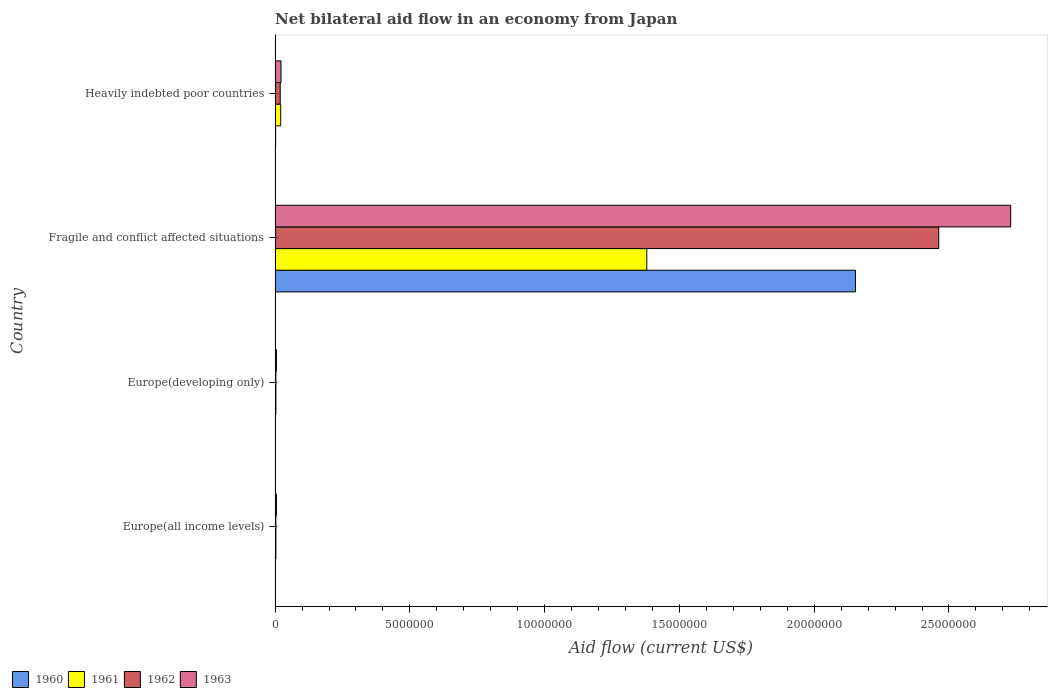How many different coloured bars are there?
Your answer should be very brief. 4. How many groups of bars are there?
Provide a succinct answer. 4. Are the number of bars on each tick of the Y-axis equal?
Ensure brevity in your answer.  Yes. How many bars are there on the 3rd tick from the top?
Ensure brevity in your answer.  4. What is the label of the 4th group of bars from the top?
Provide a short and direct response. Europe(all income levels). Across all countries, what is the maximum net bilateral aid flow in 1962?
Keep it short and to the point. 2.46e+07. In which country was the net bilateral aid flow in 1960 maximum?
Keep it short and to the point. Fragile and conflict affected situations. In which country was the net bilateral aid flow in 1962 minimum?
Provide a short and direct response. Europe(all income levels). What is the total net bilateral aid flow in 1960 in the graph?
Provide a short and direct response. 2.16e+07. What is the difference between the net bilateral aid flow in 1962 in Europe(all income levels) and that in Fragile and conflict affected situations?
Make the answer very short. -2.46e+07. What is the difference between the net bilateral aid flow in 1960 in Fragile and conflict affected situations and the net bilateral aid flow in 1962 in Europe(developing only)?
Your answer should be compact. 2.15e+07. What is the average net bilateral aid flow in 1963 per country?
Make the answer very short. 6.90e+06. What is the ratio of the net bilateral aid flow in 1962 in Europe(all income levels) to that in Europe(developing only)?
Provide a succinct answer. 1. Is the difference between the net bilateral aid flow in 1963 in Fragile and conflict affected situations and Heavily indebted poor countries greater than the difference between the net bilateral aid flow in 1961 in Fragile and conflict affected situations and Heavily indebted poor countries?
Ensure brevity in your answer.  Yes. What is the difference between the highest and the second highest net bilateral aid flow in 1961?
Your answer should be compact. 1.36e+07. What is the difference between the highest and the lowest net bilateral aid flow in 1963?
Provide a succinct answer. 2.72e+07. What does the 4th bar from the top in Europe(developing only) represents?
Your answer should be very brief. 1960. Are all the bars in the graph horizontal?
Keep it short and to the point. Yes. What is the difference between two consecutive major ticks on the X-axis?
Provide a succinct answer. 5.00e+06. Are the values on the major ticks of X-axis written in scientific E-notation?
Ensure brevity in your answer.  No. Does the graph contain any zero values?
Offer a terse response. No. Does the graph contain grids?
Give a very brief answer. No. Where does the legend appear in the graph?
Keep it short and to the point. Bottom left. How many legend labels are there?
Make the answer very short. 4. What is the title of the graph?
Ensure brevity in your answer.  Net bilateral aid flow in an economy from Japan. Does "2003" appear as one of the legend labels in the graph?
Offer a very short reply. No. What is the Aid flow (current US$) of 1961 in Europe(all income levels)?
Your response must be concise. 3.00e+04. What is the Aid flow (current US$) of 1962 in Europe(all income levels)?
Make the answer very short. 3.00e+04. What is the Aid flow (current US$) in 1960 in Fragile and conflict affected situations?
Your answer should be compact. 2.15e+07. What is the Aid flow (current US$) of 1961 in Fragile and conflict affected situations?
Provide a succinct answer. 1.38e+07. What is the Aid flow (current US$) of 1962 in Fragile and conflict affected situations?
Ensure brevity in your answer.  2.46e+07. What is the Aid flow (current US$) of 1963 in Fragile and conflict affected situations?
Make the answer very short. 2.73e+07. What is the Aid flow (current US$) in 1962 in Heavily indebted poor countries?
Make the answer very short. 1.90e+05. What is the Aid flow (current US$) in 1963 in Heavily indebted poor countries?
Your response must be concise. 2.20e+05. Across all countries, what is the maximum Aid flow (current US$) of 1960?
Ensure brevity in your answer.  2.15e+07. Across all countries, what is the maximum Aid flow (current US$) of 1961?
Provide a short and direct response. 1.38e+07. Across all countries, what is the maximum Aid flow (current US$) in 1962?
Ensure brevity in your answer.  2.46e+07. Across all countries, what is the maximum Aid flow (current US$) in 1963?
Your answer should be very brief. 2.73e+07. Across all countries, what is the minimum Aid flow (current US$) of 1962?
Offer a very short reply. 3.00e+04. What is the total Aid flow (current US$) of 1960 in the graph?
Offer a terse response. 2.16e+07. What is the total Aid flow (current US$) in 1961 in the graph?
Offer a very short reply. 1.41e+07. What is the total Aid flow (current US$) of 1962 in the graph?
Give a very brief answer. 2.49e+07. What is the total Aid flow (current US$) in 1963 in the graph?
Your answer should be very brief. 2.76e+07. What is the difference between the Aid flow (current US$) in 1961 in Europe(all income levels) and that in Europe(developing only)?
Make the answer very short. 0. What is the difference between the Aid flow (current US$) in 1962 in Europe(all income levels) and that in Europe(developing only)?
Your answer should be very brief. 0. What is the difference between the Aid flow (current US$) of 1963 in Europe(all income levels) and that in Europe(developing only)?
Give a very brief answer. 0. What is the difference between the Aid flow (current US$) of 1960 in Europe(all income levels) and that in Fragile and conflict affected situations?
Give a very brief answer. -2.15e+07. What is the difference between the Aid flow (current US$) in 1961 in Europe(all income levels) and that in Fragile and conflict affected situations?
Your answer should be very brief. -1.38e+07. What is the difference between the Aid flow (current US$) in 1962 in Europe(all income levels) and that in Fragile and conflict affected situations?
Ensure brevity in your answer.  -2.46e+07. What is the difference between the Aid flow (current US$) in 1963 in Europe(all income levels) and that in Fragile and conflict affected situations?
Give a very brief answer. -2.72e+07. What is the difference between the Aid flow (current US$) of 1961 in Europe(all income levels) and that in Heavily indebted poor countries?
Your answer should be very brief. -1.80e+05. What is the difference between the Aid flow (current US$) in 1962 in Europe(all income levels) and that in Heavily indebted poor countries?
Offer a very short reply. -1.60e+05. What is the difference between the Aid flow (current US$) of 1960 in Europe(developing only) and that in Fragile and conflict affected situations?
Provide a succinct answer. -2.15e+07. What is the difference between the Aid flow (current US$) of 1961 in Europe(developing only) and that in Fragile and conflict affected situations?
Your answer should be compact. -1.38e+07. What is the difference between the Aid flow (current US$) in 1962 in Europe(developing only) and that in Fragile and conflict affected situations?
Your answer should be compact. -2.46e+07. What is the difference between the Aid flow (current US$) of 1963 in Europe(developing only) and that in Fragile and conflict affected situations?
Your answer should be compact. -2.72e+07. What is the difference between the Aid flow (current US$) of 1960 in Fragile and conflict affected situations and that in Heavily indebted poor countries?
Ensure brevity in your answer.  2.15e+07. What is the difference between the Aid flow (current US$) in 1961 in Fragile and conflict affected situations and that in Heavily indebted poor countries?
Your response must be concise. 1.36e+07. What is the difference between the Aid flow (current US$) of 1962 in Fragile and conflict affected situations and that in Heavily indebted poor countries?
Your answer should be very brief. 2.44e+07. What is the difference between the Aid flow (current US$) of 1963 in Fragile and conflict affected situations and that in Heavily indebted poor countries?
Provide a short and direct response. 2.71e+07. What is the difference between the Aid flow (current US$) in 1960 in Europe(all income levels) and the Aid flow (current US$) in 1961 in Europe(developing only)?
Provide a short and direct response. -2.00e+04. What is the difference between the Aid flow (current US$) in 1960 in Europe(all income levels) and the Aid flow (current US$) in 1963 in Europe(developing only)?
Provide a short and direct response. -4.00e+04. What is the difference between the Aid flow (current US$) of 1961 in Europe(all income levels) and the Aid flow (current US$) of 1962 in Europe(developing only)?
Provide a succinct answer. 0. What is the difference between the Aid flow (current US$) of 1960 in Europe(all income levels) and the Aid flow (current US$) of 1961 in Fragile and conflict affected situations?
Your answer should be compact. -1.38e+07. What is the difference between the Aid flow (current US$) in 1960 in Europe(all income levels) and the Aid flow (current US$) in 1962 in Fragile and conflict affected situations?
Keep it short and to the point. -2.46e+07. What is the difference between the Aid flow (current US$) of 1960 in Europe(all income levels) and the Aid flow (current US$) of 1963 in Fragile and conflict affected situations?
Offer a terse response. -2.73e+07. What is the difference between the Aid flow (current US$) of 1961 in Europe(all income levels) and the Aid flow (current US$) of 1962 in Fragile and conflict affected situations?
Your answer should be very brief. -2.46e+07. What is the difference between the Aid flow (current US$) in 1961 in Europe(all income levels) and the Aid flow (current US$) in 1963 in Fragile and conflict affected situations?
Give a very brief answer. -2.73e+07. What is the difference between the Aid flow (current US$) in 1962 in Europe(all income levels) and the Aid flow (current US$) in 1963 in Fragile and conflict affected situations?
Make the answer very short. -2.73e+07. What is the difference between the Aid flow (current US$) of 1960 in Europe(all income levels) and the Aid flow (current US$) of 1961 in Heavily indebted poor countries?
Your answer should be compact. -2.00e+05. What is the difference between the Aid flow (current US$) in 1960 in Europe(all income levels) and the Aid flow (current US$) in 1962 in Heavily indebted poor countries?
Offer a terse response. -1.80e+05. What is the difference between the Aid flow (current US$) of 1960 in Europe(all income levels) and the Aid flow (current US$) of 1963 in Heavily indebted poor countries?
Offer a terse response. -2.10e+05. What is the difference between the Aid flow (current US$) of 1961 in Europe(all income levels) and the Aid flow (current US$) of 1962 in Heavily indebted poor countries?
Provide a short and direct response. -1.60e+05. What is the difference between the Aid flow (current US$) in 1960 in Europe(developing only) and the Aid flow (current US$) in 1961 in Fragile and conflict affected situations?
Ensure brevity in your answer.  -1.38e+07. What is the difference between the Aid flow (current US$) of 1960 in Europe(developing only) and the Aid flow (current US$) of 1962 in Fragile and conflict affected situations?
Provide a succinct answer. -2.46e+07. What is the difference between the Aid flow (current US$) of 1960 in Europe(developing only) and the Aid flow (current US$) of 1963 in Fragile and conflict affected situations?
Give a very brief answer. -2.73e+07. What is the difference between the Aid flow (current US$) in 1961 in Europe(developing only) and the Aid flow (current US$) in 1962 in Fragile and conflict affected situations?
Your answer should be compact. -2.46e+07. What is the difference between the Aid flow (current US$) in 1961 in Europe(developing only) and the Aid flow (current US$) in 1963 in Fragile and conflict affected situations?
Your answer should be compact. -2.73e+07. What is the difference between the Aid flow (current US$) in 1962 in Europe(developing only) and the Aid flow (current US$) in 1963 in Fragile and conflict affected situations?
Make the answer very short. -2.73e+07. What is the difference between the Aid flow (current US$) in 1960 in Europe(developing only) and the Aid flow (current US$) in 1963 in Heavily indebted poor countries?
Keep it short and to the point. -2.10e+05. What is the difference between the Aid flow (current US$) of 1962 in Europe(developing only) and the Aid flow (current US$) of 1963 in Heavily indebted poor countries?
Keep it short and to the point. -1.90e+05. What is the difference between the Aid flow (current US$) in 1960 in Fragile and conflict affected situations and the Aid flow (current US$) in 1961 in Heavily indebted poor countries?
Ensure brevity in your answer.  2.13e+07. What is the difference between the Aid flow (current US$) in 1960 in Fragile and conflict affected situations and the Aid flow (current US$) in 1962 in Heavily indebted poor countries?
Your response must be concise. 2.13e+07. What is the difference between the Aid flow (current US$) in 1960 in Fragile and conflict affected situations and the Aid flow (current US$) in 1963 in Heavily indebted poor countries?
Give a very brief answer. 2.13e+07. What is the difference between the Aid flow (current US$) of 1961 in Fragile and conflict affected situations and the Aid flow (current US$) of 1962 in Heavily indebted poor countries?
Offer a terse response. 1.36e+07. What is the difference between the Aid flow (current US$) in 1961 in Fragile and conflict affected situations and the Aid flow (current US$) in 1963 in Heavily indebted poor countries?
Offer a terse response. 1.36e+07. What is the difference between the Aid flow (current US$) of 1962 in Fragile and conflict affected situations and the Aid flow (current US$) of 1963 in Heavily indebted poor countries?
Offer a very short reply. 2.44e+07. What is the average Aid flow (current US$) in 1960 per country?
Give a very brief answer. 5.39e+06. What is the average Aid flow (current US$) in 1961 per country?
Give a very brief answer. 3.52e+06. What is the average Aid flow (current US$) in 1962 per country?
Ensure brevity in your answer.  6.22e+06. What is the average Aid flow (current US$) of 1963 per country?
Give a very brief answer. 6.90e+06. What is the difference between the Aid flow (current US$) of 1960 and Aid flow (current US$) of 1961 in Europe(all income levels)?
Provide a succinct answer. -2.00e+04. What is the difference between the Aid flow (current US$) of 1960 and Aid flow (current US$) of 1962 in Europe(all income levels)?
Your response must be concise. -2.00e+04. What is the difference between the Aid flow (current US$) of 1960 and Aid flow (current US$) of 1963 in Europe(all income levels)?
Provide a short and direct response. -4.00e+04. What is the difference between the Aid flow (current US$) in 1960 and Aid flow (current US$) in 1961 in Europe(developing only)?
Your response must be concise. -2.00e+04. What is the difference between the Aid flow (current US$) of 1960 and Aid flow (current US$) of 1963 in Europe(developing only)?
Your answer should be very brief. -4.00e+04. What is the difference between the Aid flow (current US$) in 1961 and Aid flow (current US$) in 1962 in Europe(developing only)?
Ensure brevity in your answer.  0. What is the difference between the Aid flow (current US$) in 1960 and Aid flow (current US$) in 1961 in Fragile and conflict affected situations?
Offer a very short reply. 7.74e+06. What is the difference between the Aid flow (current US$) of 1960 and Aid flow (current US$) of 1962 in Fragile and conflict affected situations?
Provide a short and direct response. -3.09e+06. What is the difference between the Aid flow (current US$) in 1960 and Aid flow (current US$) in 1963 in Fragile and conflict affected situations?
Your response must be concise. -5.76e+06. What is the difference between the Aid flow (current US$) of 1961 and Aid flow (current US$) of 1962 in Fragile and conflict affected situations?
Your answer should be very brief. -1.08e+07. What is the difference between the Aid flow (current US$) in 1961 and Aid flow (current US$) in 1963 in Fragile and conflict affected situations?
Your answer should be very brief. -1.35e+07. What is the difference between the Aid flow (current US$) in 1962 and Aid flow (current US$) in 1963 in Fragile and conflict affected situations?
Offer a very short reply. -2.67e+06. What is the difference between the Aid flow (current US$) in 1960 and Aid flow (current US$) in 1961 in Heavily indebted poor countries?
Provide a short and direct response. -1.90e+05. What is the difference between the Aid flow (current US$) of 1960 and Aid flow (current US$) of 1962 in Heavily indebted poor countries?
Your answer should be very brief. -1.70e+05. What is the difference between the Aid flow (current US$) of 1960 and Aid flow (current US$) of 1963 in Heavily indebted poor countries?
Offer a terse response. -2.00e+05. What is the difference between the Aid flow (current US$) of 1962 and Aid flow (current US$) of 1963 in Heavily indebted poor countries?
Provide a succinct answer. -3.00e+04. What is the ratio of the Aid flow (current US$) in 1960 in Europe(all income levels) to that in Europe(developing only)?
Provide a short and direct response. 1. What is the ratio of the Aid flow (current US$) of 1961 in Europe(all income levels) to that in Europe(developing only)?
Make the answer very short. 1. What is the ratio of the Aid flow (current US$) of 1962 in Europe(all income levels) to that in Europe(developing only)?
Your response must be concise. 1. What is the ratio of the Aid flow (current US$) in 1960 in Europe(all income levels) to that in Fragile and conflict affected situations?
Your response must be concise. 0. What is the ratio of the Aid flow (current US$) in 1961 in Europe(all income levels) to that in Fragile and conflict affected situations?
Ensure brevity in your answer.  0. What is the ratio of the Aid flow (current US$) of 1962 in Europe(all income levels) to that in Fragile and conflict affected situations?
Offer a terse response. 0. What is the ratio of the Aid flow (current US$) in 1963 in Europe(all income levels) to that in Fragile and conflict affected situations?
Give a very brief answer. 0. What is the ratio of the Aid flow (current US$) in 1960 in Europe(all income levels) to that in Heavily indebted poor countries?
Your answer should be compact. 0.5. What is the ratio of the Aid flow (current US$) in 1961 in Europe(all income levels) to that in Heavily indebted poor countries?
Provide a succinct answer. 0.14. What is the ratio of the Aid flow (current US$) in 1962 in Europe(all income levels) to that in Heavily indebted poor countries?
Keep it short and to the point. 0.16. What is the ratio of the Aid flow (current US$) of 1963 in Europe(all income levels) to that in Heavily indebted poor countries?
Provide a succinct answer. 0.23. What is the ratio of the Aid flow (current US$) in 1960 in Europe(developing only) to that in Fragile and conflict affected situations?
Offer a terse response. 0. What is the ratio of the Aid flow (current US$) in 1961 in Europe(developing only) to that in Fragile and conflict affected situations?
Give a very brief answer. 0. What is the ratio of the Aid flow (current US$) in 1962 in Europe(developing only) to that in Fragile and conflict affected situations?
Ensure brevity in your answer.  0. What is the ratio of the Aid flow (current US$) of 1963 in Europe(developing only) to that in Fragile and conflict affected situations?
Your answer should be very brief. 0. What is the ratio of the Aid flow (current US$) of 1960 in Europe(developing only) to that in Heavily indebted poor countries?
Give a very brief answer. 0.5. What is the ratio of the Aid flow (current US$) in 1961 in Europe(developing only) to that in Heavily indebted poor countries?
Provide a succinct answer. 0.14. What is the ratio of the Aid flow (current US$) in 1962 in Europe(developing only) to that in Heavily indebted poor countries?
Your response must be concise. 0.16. What is the ratio of the Aid flow (current US$) of 1963 in Europe(developing only) to that in Heavily indebted poor countries?
Keep it short and to the point. 0.23. What is the ratio of the Aid flow (current US$) in 1960 in Fragile and conflict affected situations to that in Heavily indebted poor countries?
Provide a short and direct response. 1076.5. What is the ratio of the Aid flow (current US$) in 1961 in Fragile and conflict affected situations to that in Heavily indebted poor countries?
Your response must be concise. 65.67. What is the ratio of the Aid flow (current US$) in 1962 in Fragile and conflict affected situations to that in Heavily indebted poor countries?
Ensure brevity in your answer.  129.58. What is the ratio of the Aid flow (current US$) in 1963 in Fragile and conflict affected situations to that in Heavily indebted poor countries?
Offer a very short reply. 124.05. What is the difference between the highest and the second highest Aid flow (current US$) in 1960?
Offer a terse response. 2.15e+07. What is the difference between the highest and the second highest Aid flow (current US$) of 1961?
Offer a terse response. 1.36e+07. What is the difference between the highest and the second highest Aid flow (current US$) in 1962?
Your answer should be compact. 2.44e+07. What is the difference between the highest and the second highest Aid flow (current US$) of 1963?
Offer a terse response. 2.71e+07. What is the difference between the highest and the lowest Aid flow (current US$) of 1960?
Make the answer very short. 2.15e+07. What is the difference between the highest and the lowest Aid flow (current US$) in 1961?
Ensure brevity in your answer.  1.38e+07. What is the difference between the highest and the lowest Aid flow (current US$) in 1962?
Provide a succinct answer. 2.46e+07. What is the difference between the highest and the lowest Aid flow (current US$) of 1963?
Your answer should be very brief. 2.72e+07. 